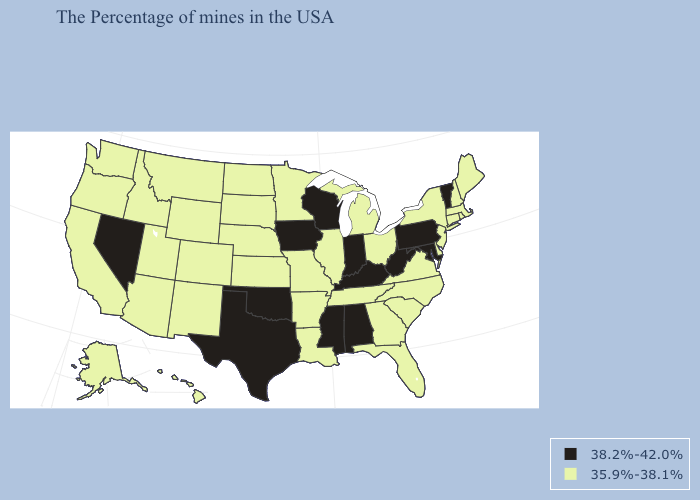Does the map have missing data?
Answer briefly. No. Name the states that have a value in the range 38.2%-42.0%?
Write a very short answer. Vermont, Maryland, Pennsylvania, West Virginia, Kentucky, Indiana, Alabama, Wisconsin, Mississippi, Iowa, Oklahoma, Texas, Nevada. Name the states that have a value in the range 38.2%-42.0%?
Be succinct. Vermont, Maryland, Pennsylvania, West Virginia, Kentucky, Indiana, Alabama, Wisconsin, Mississippi, Iowa, Oklahoma, Texas, Nevada. Does Illinois have the highest value in the MidWest?
Be succinct. No. What is the highest value in states that border New Mexico?
Answer briefly. 38.2%-42.0%. Does Massachusetts have the highest value in the USA?
Answer briefly. No. Does Rhode Island have a lower value than Pennsylvania?
Concise answer only. Yes. Name the states that have a value in the range 35.9%-38.1%?
Quick response, please. Maine, Massachusetts, Rhode Island, New Hampshire, Connecticut, New York, New Jersey, Delaware, Virginia, North Carolina, South Carolina, Ohio, Florida, Georgia, Michigan, Tennessee, Illinois, Louisiana, Missouri, Arkansas, Minnesota, Kansas, Nebraska, South Dakota, North Dakota, Wyoming, Colorado, New Mexico, Utah, Montana, Arizona, Idaho, California, Washington, Oregon, Alaska, Hawaii. Name the states that have a value in the range 35.9%-38.1%?
Give a very brief answer. Maine, Massachusetts, Rhode Island, New Hampshire, Connecticut, New York, New Jersey, Delaware, Virginia, North Carolina, South Carolina, Ohio, Florida, Georgia, Michigan, Tennessee, Illinois, Louisiana, Missouri, Arkansas, Minnesota, Kansas, Nebraska, South Dakota, North Dakota, Wyoming, Colorado, New Mexico, Utah, Montana, Arizona, Idaho, California, Washington, Oregon, Alaska, Hawaii. What is the lowest value in the MidWest?
Write a very short answer. 35.9%-38.1%. Does Pennsylvania have a higher value than Kentucky?
Write a very short answer. No. Does Vermont have the lowest value in the USA?
Answer briefly. No. What is the value of Mississippi?
Keep it brief. 38.2%-42.0%. Does Ohio have the lowest value in the USA?
Give a very brief answer. Yes. 